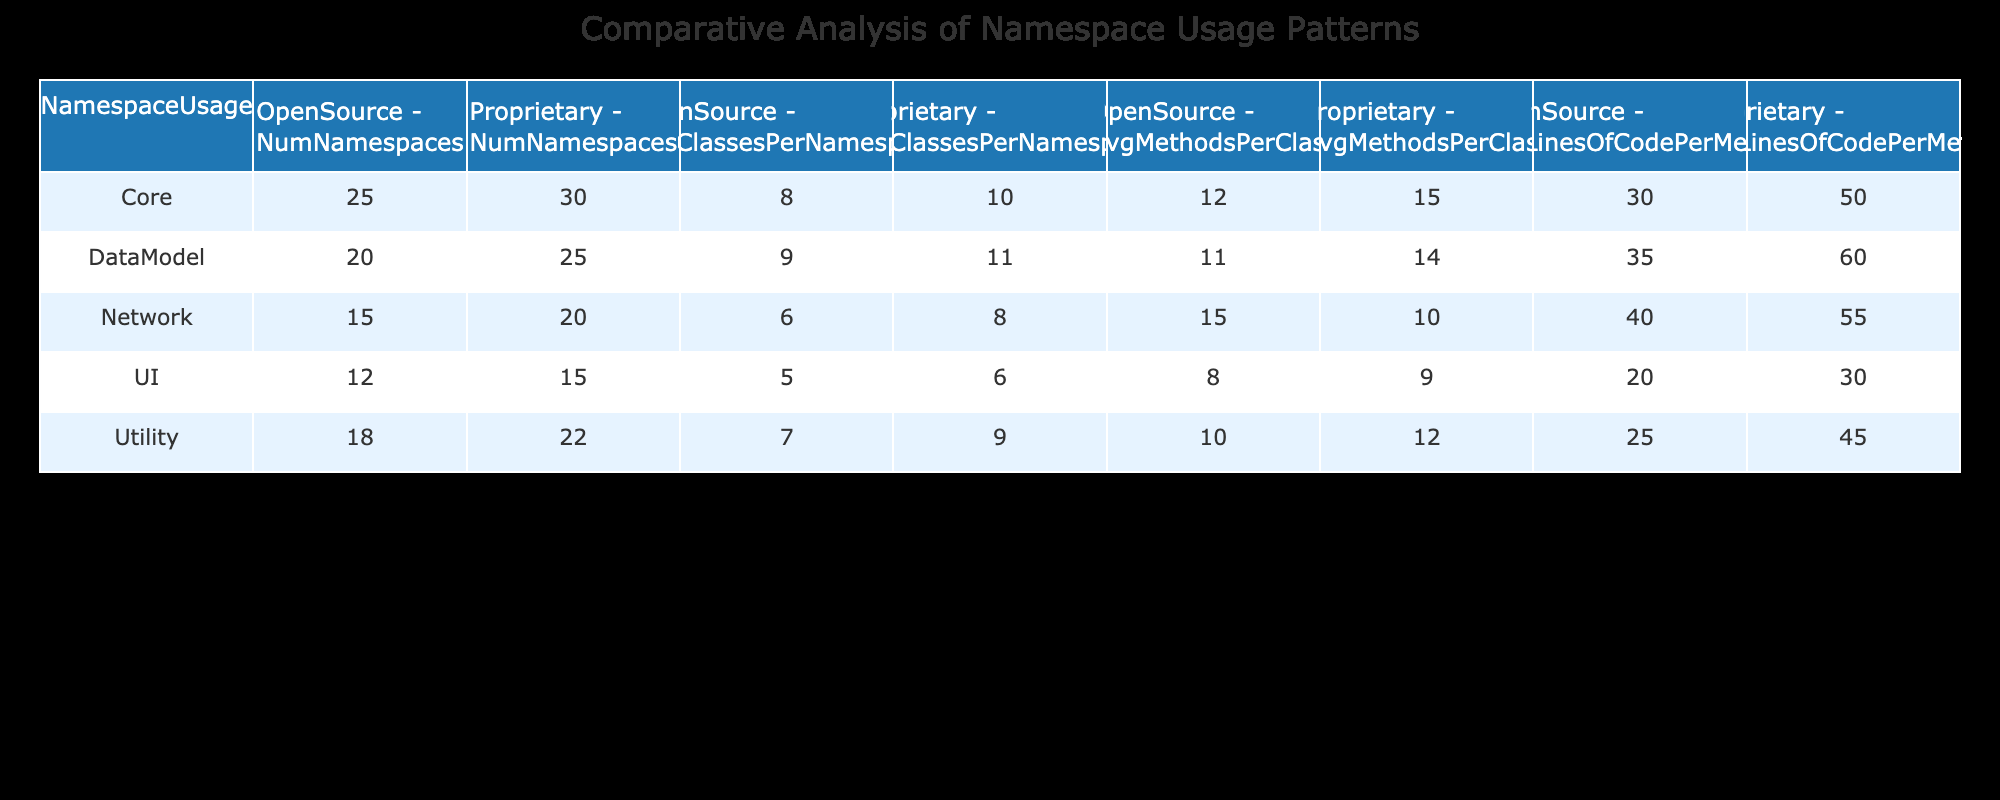What is the number of namespaces used in open-source software for the DataModel namespace? According to the table, the number of namespaces associated with the DataModel in open-source software is listed under the "NumNamespaces" column. For the DataModel row under the OpenSource column, the value is 20.
Answer: 20 What is the average number of classes per namespace in proprietary software for the Core namespace? The average number of classes per namespace for the Core namespace in proprietary software is found in the AvgClassesPerNamespace column. The value for Core under Proprietary is 10.
Answer: 10 True or False: The average lines of code per method in the Network namespace for open-source software is greater than that of proprietary software. By examining the AvgLinesOfCodePerMethod values, the open-source Network namespace has 40 lines of code per method, while the proprietary counterpart has 55 lines. Since 40 is not greater than 55, the statement is false.
Answer: False What is the total number of namespaces for proprietary software across all namespace usages? To calculate the total, add the NumNamespaces for each proprietary namespace: 30 (Core) + 22 (Utility) + 25 (DataModel) + 20 (Network) + 15 (UI) = 112. Therefore, the total number of namespaces for proprietary software is 112.
Answer: 112 What is the difference in the average methods per class between open-source and proprietary software for the Utility namespace? First, look at the AvgMethodsPerClass for both software types under the Utility namespace. Open-source shows 10 methods per class, and proprietary shows 12. The difference is calculated as 12 (proprietary) - 10 (open-source) = 2.
Answer: 2 True or False: The average classes per namespace is consistently higher for proprietary software compared to open-source software. Checking the AvgClassesPerNamespace for each namespace, the averages are: Core (10 vs. 8), Utility (9 vs. 7), DataModel (11 vs. 9), Network (8 vs. 6), and UI (6 vs. 5). All proprietary values are higher than the corresponding open-source values, confirming the statement is true.
Answer: True What is the average number of methods per class for open-source software across all namespaces? To find this average, sum the AvgMethodsPerClass for open-source software: 12 (Core) + 10 (Utility) + 11 (DataModel) + 15 (Network) + 8 (UI) = 56. There are 5 namespaces, so the average is 56 / 5 = 11.2.
Answer: 11.2 Which namespace in proprietary software has the highest average lines of code per method? By checking the AvgLinesOfCodePerMethod for proprietary namespaces: Core (50), Utility (45), DataModel (60), Network (55), and UI (30), it can be seen that DataModel has the highest value at 60.
Answer: DataModel 